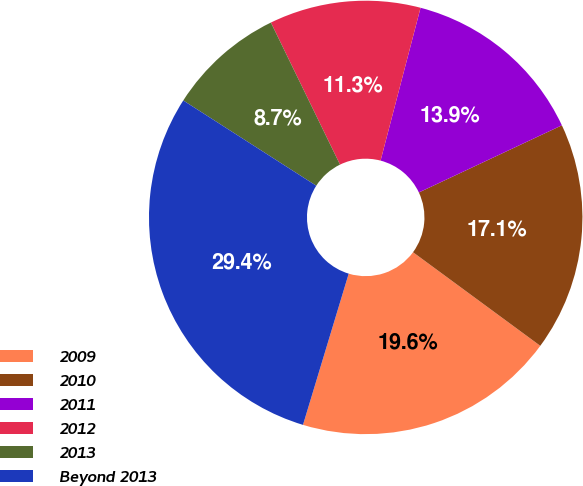Convert chart. <chart><loc_0><loc_0><loc_500><loc_500><pie_chart><fcel>2009<fcel>2010<fcel>2011<fcel>2012<fcel>2013<fcel>Beyond 2013<nl><fcel>19.58%<fcel>17.08%<fcel>13.94%<fcel>11.28%<fcel>8.72%<fcel>29.4%<nl></chart> 